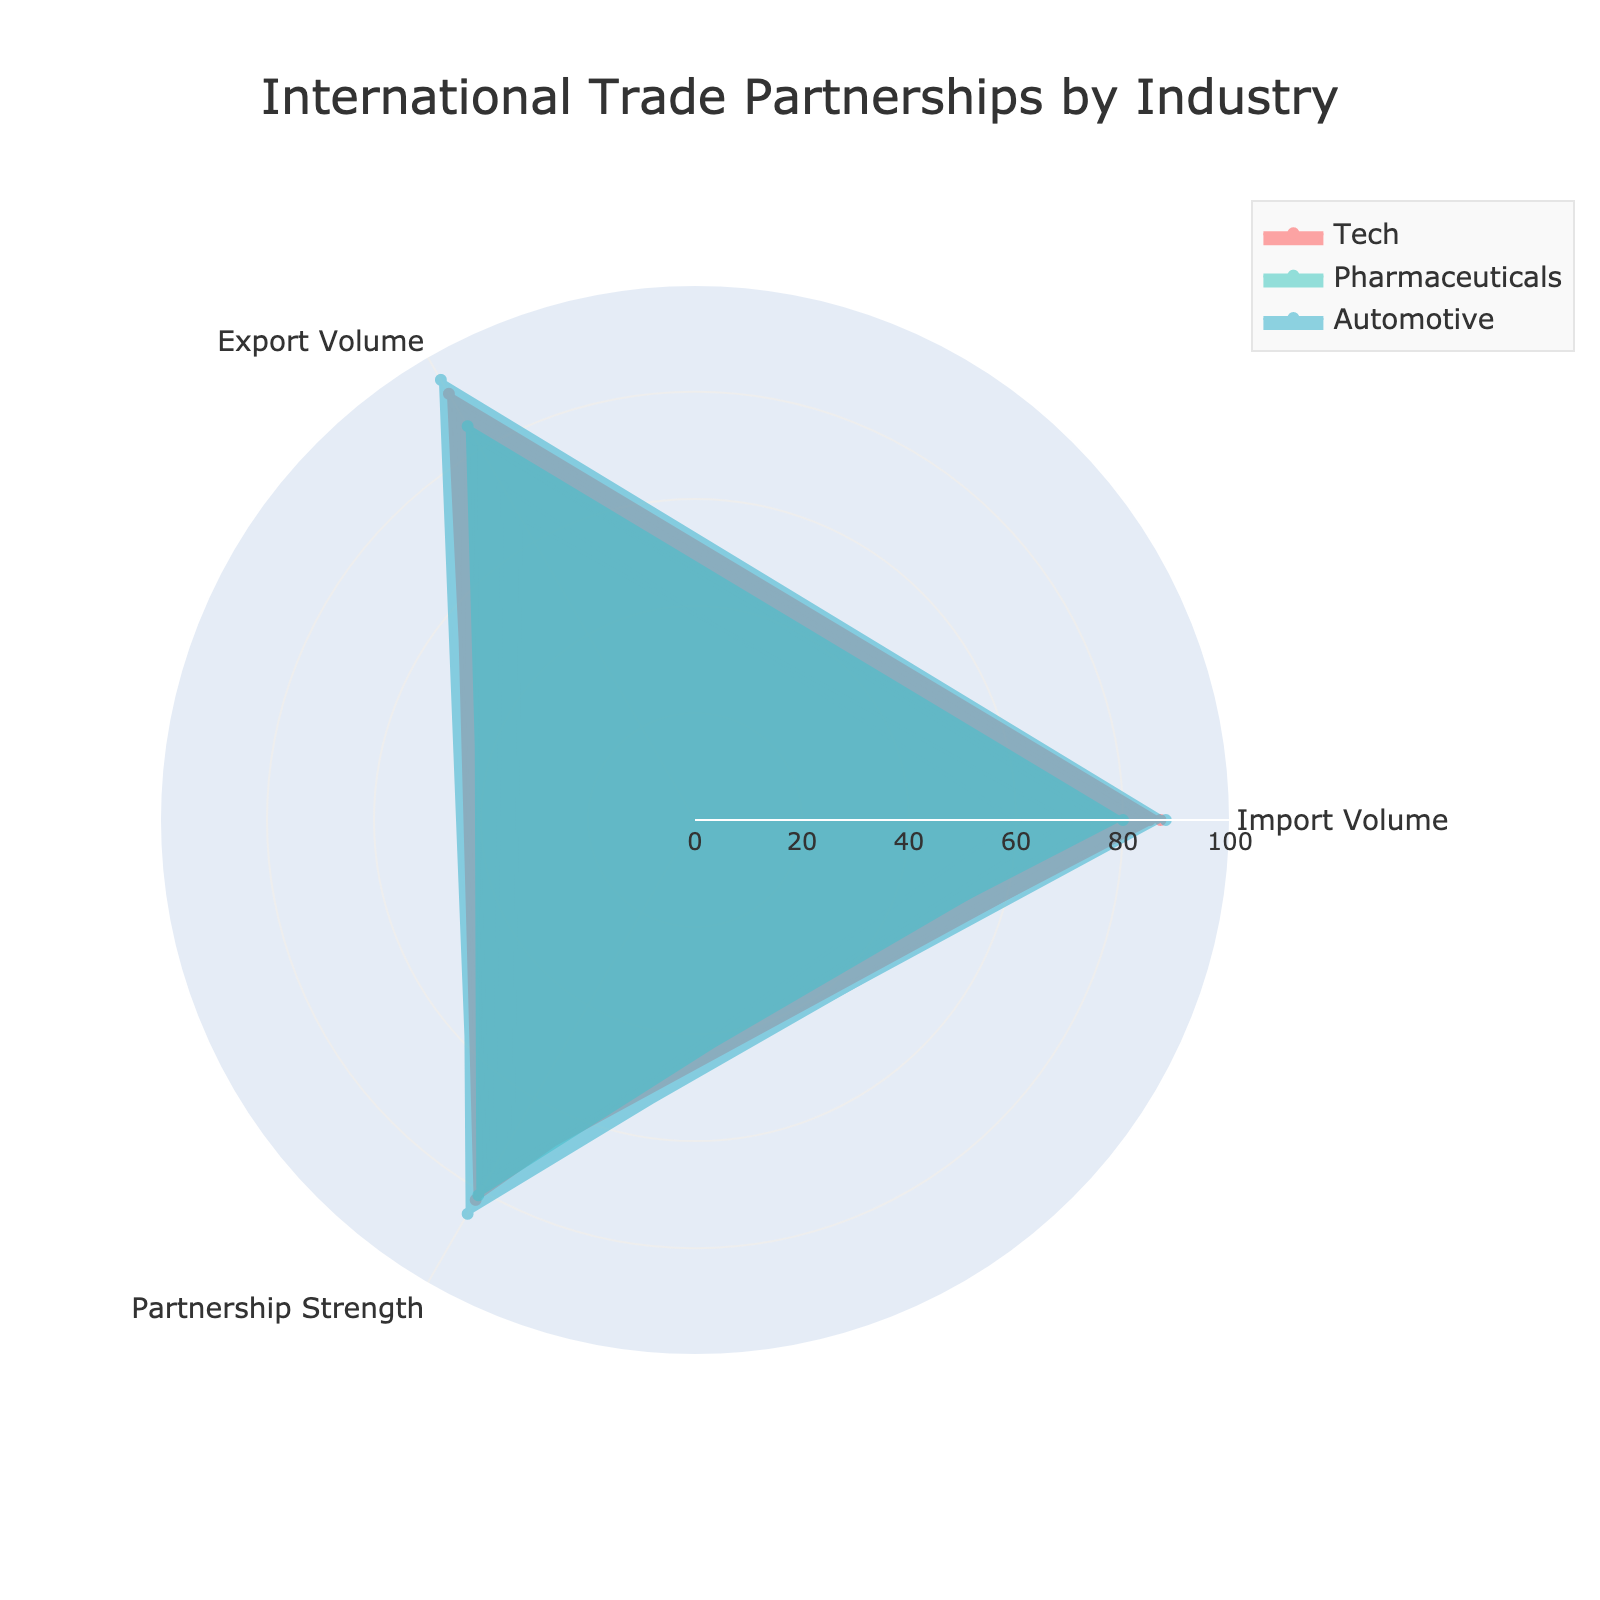What industries are represented in the radar chart? The radar chart consists of different areas coded with distinct colors, signifying distinct industries. Three areas with different colors represent the industries.
Answer: Tech, Pharmaceuticals, Automotive Which industry has the highest export volume? Upon examining the radar chart, the section correlating to export volume shows an industry peak at a value of 95. Checking the corresponding label reveals this industry.
Answer: Automotive What is the average import volume for the Tech industry? Summing the import volumes for Tech (87, 85, 60) we get 232. Dividing by the number of trade partners (3) gives us 77.33.
Answer: 77.33 Which industry has the most balanced (similar) values between import and export volumes? By comparing the shapes of each industry on the radar chart, the Pharmaceutical industry's values for import and export volume are closest to each other across trade partners.
Answer: Pharmaceuticals How does the partnership strength for Automotive in Germany compare to Tech in Germany? Referring to the values on the radial axes for partnership strength, Automotive in Germany has a partnership strength of 85 while Tech in Germany has a partnership strength of 75.
Answer: Automotive is stronger Which industry-trade partner pair has the lowest partnership strength? Examining the radar chart for the lowest point on the partnership strength axis, the lowest-value occurrence is found in Pharmaceuticals with India, showing a value of 68.
Answer: Pharmaceuticals-India What is the total export volume for all trade partners in the Automotive industry? Summing export volumes for Automotive (95, 87, 82), we calculate 264.
Answer: 264 How many data points are displayed for each industry in the radar chart? Observing the chart, each industry has three radial sets of data points corresponding to the three trade partners.
Answer: 3 What is the difference in partnership strength between the highest and lowest values across all industries? The maximum partnership strength observed is 85 (Automotive with Germany), and the minimum is 68 (Pharmaceuticals with India), resulting in a difference of 17.
Answer: 17 For which trade partners do Tech and Pharmaceuticals have similar values across all three categories? By comparing the data points in the radar chart, the values for Tech and Pharmaceuticals for the United States are closely aligned across import, export, and partnership strength.
Answer: United States 